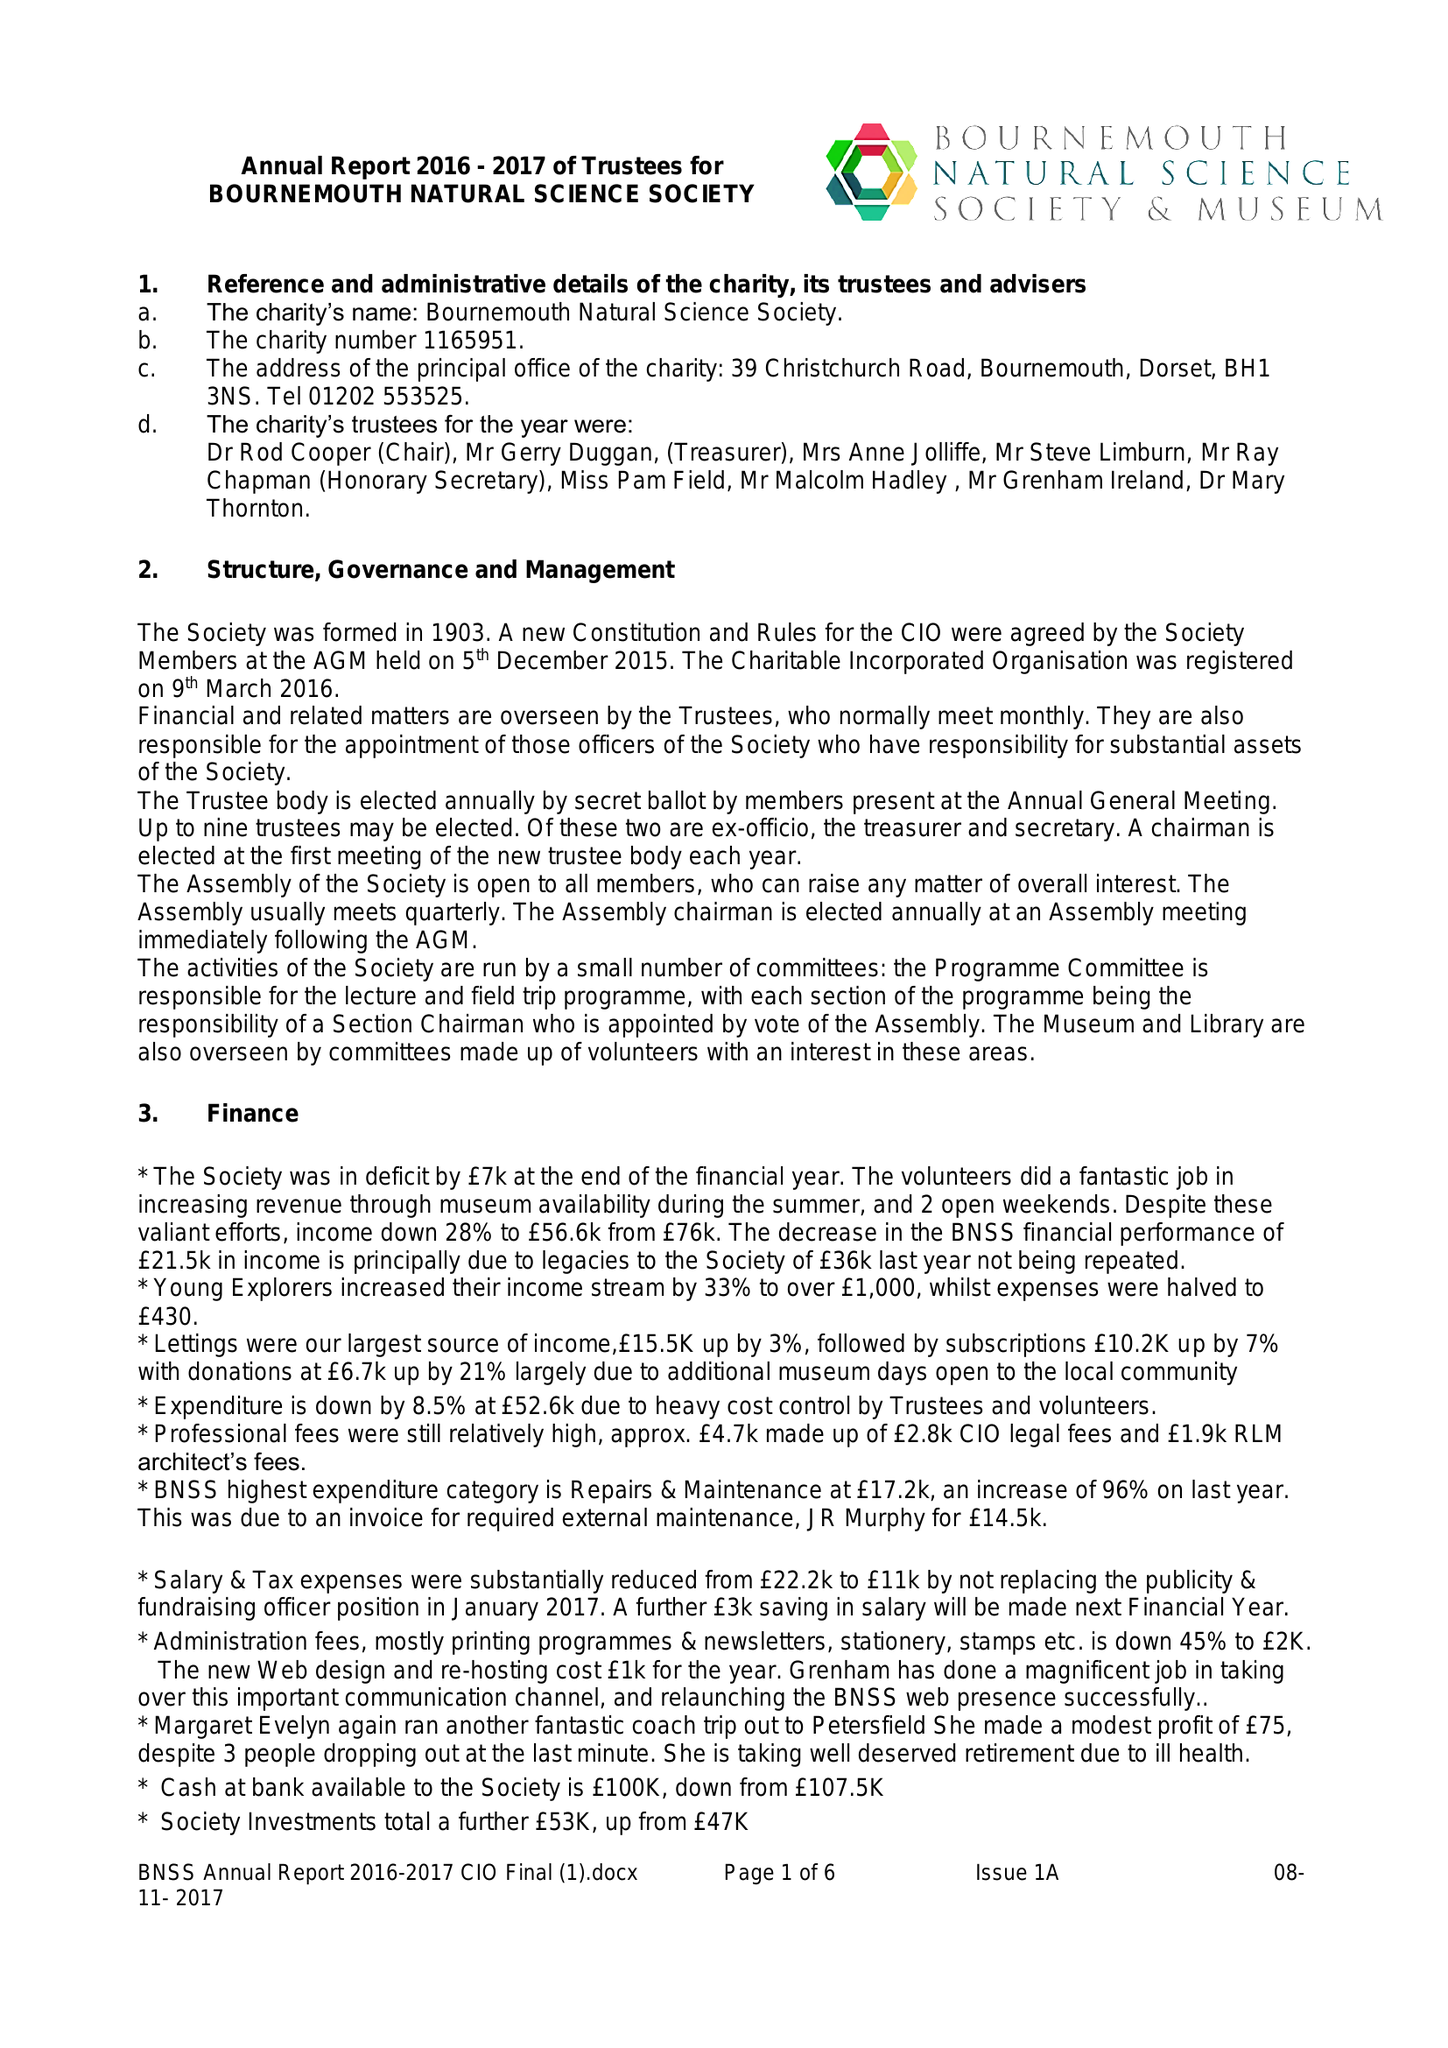What is the value for the spending_annually_in_british_pounds?
Answer the question using a single word or phrase. 52605.00 